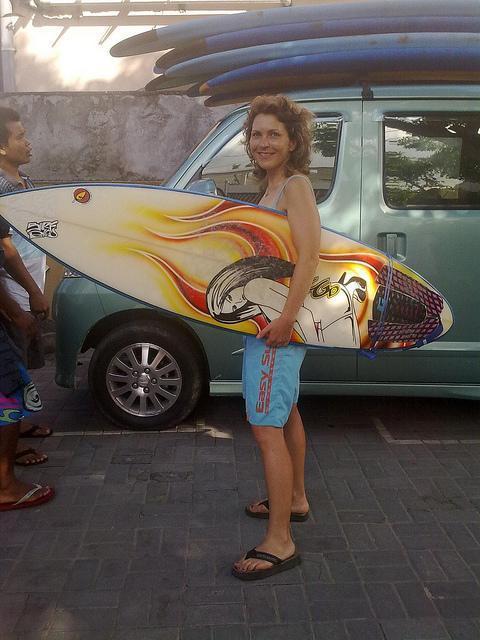How many people can you see?
Give a very brief answer. 3. 